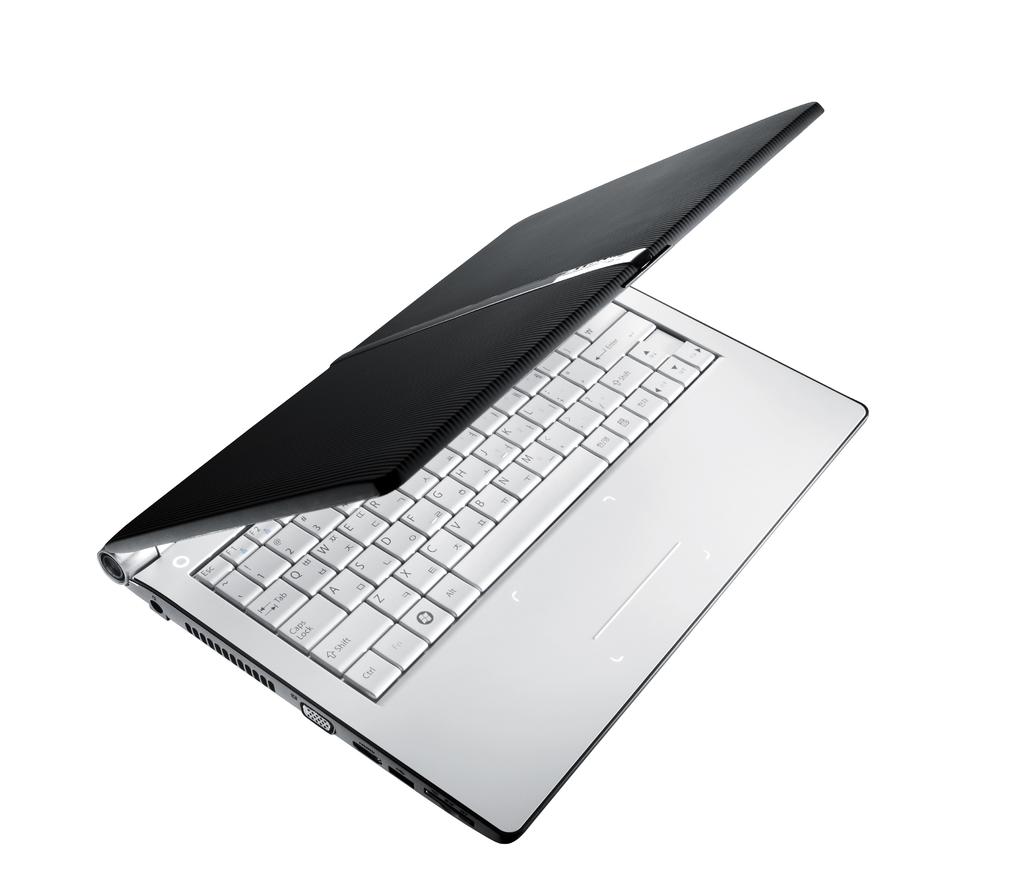What is written on the button with 2 arrows?
Your answer should be very brief. Tab. 